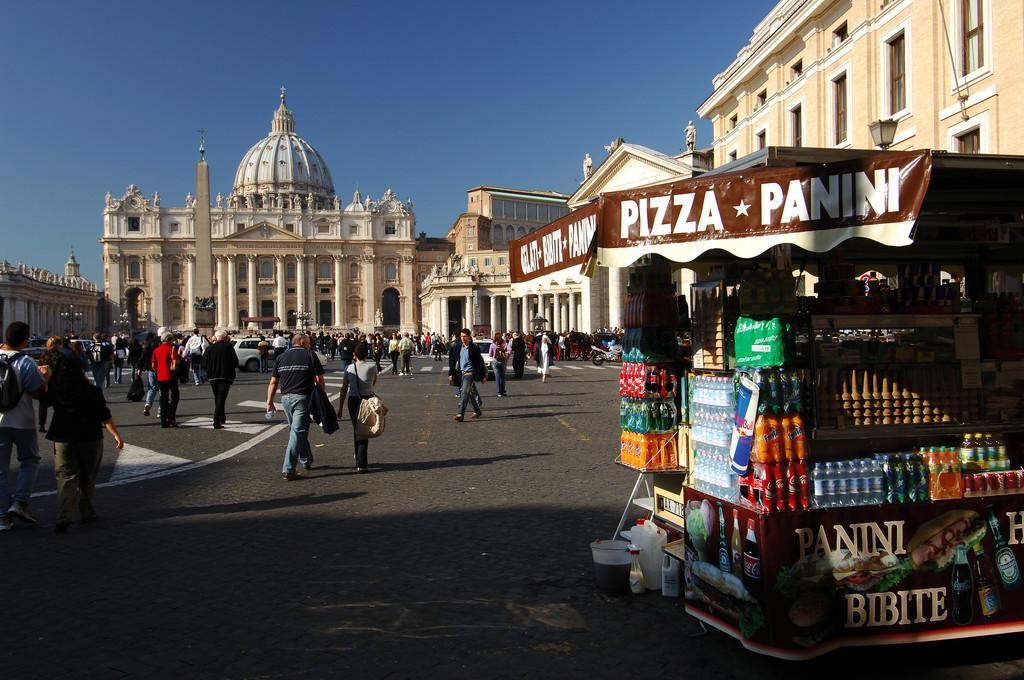Please provide a concise description of this image. In the given image I can see a castle, buildings, people, vehicles, store with some food items and in the background I can see the sky. 